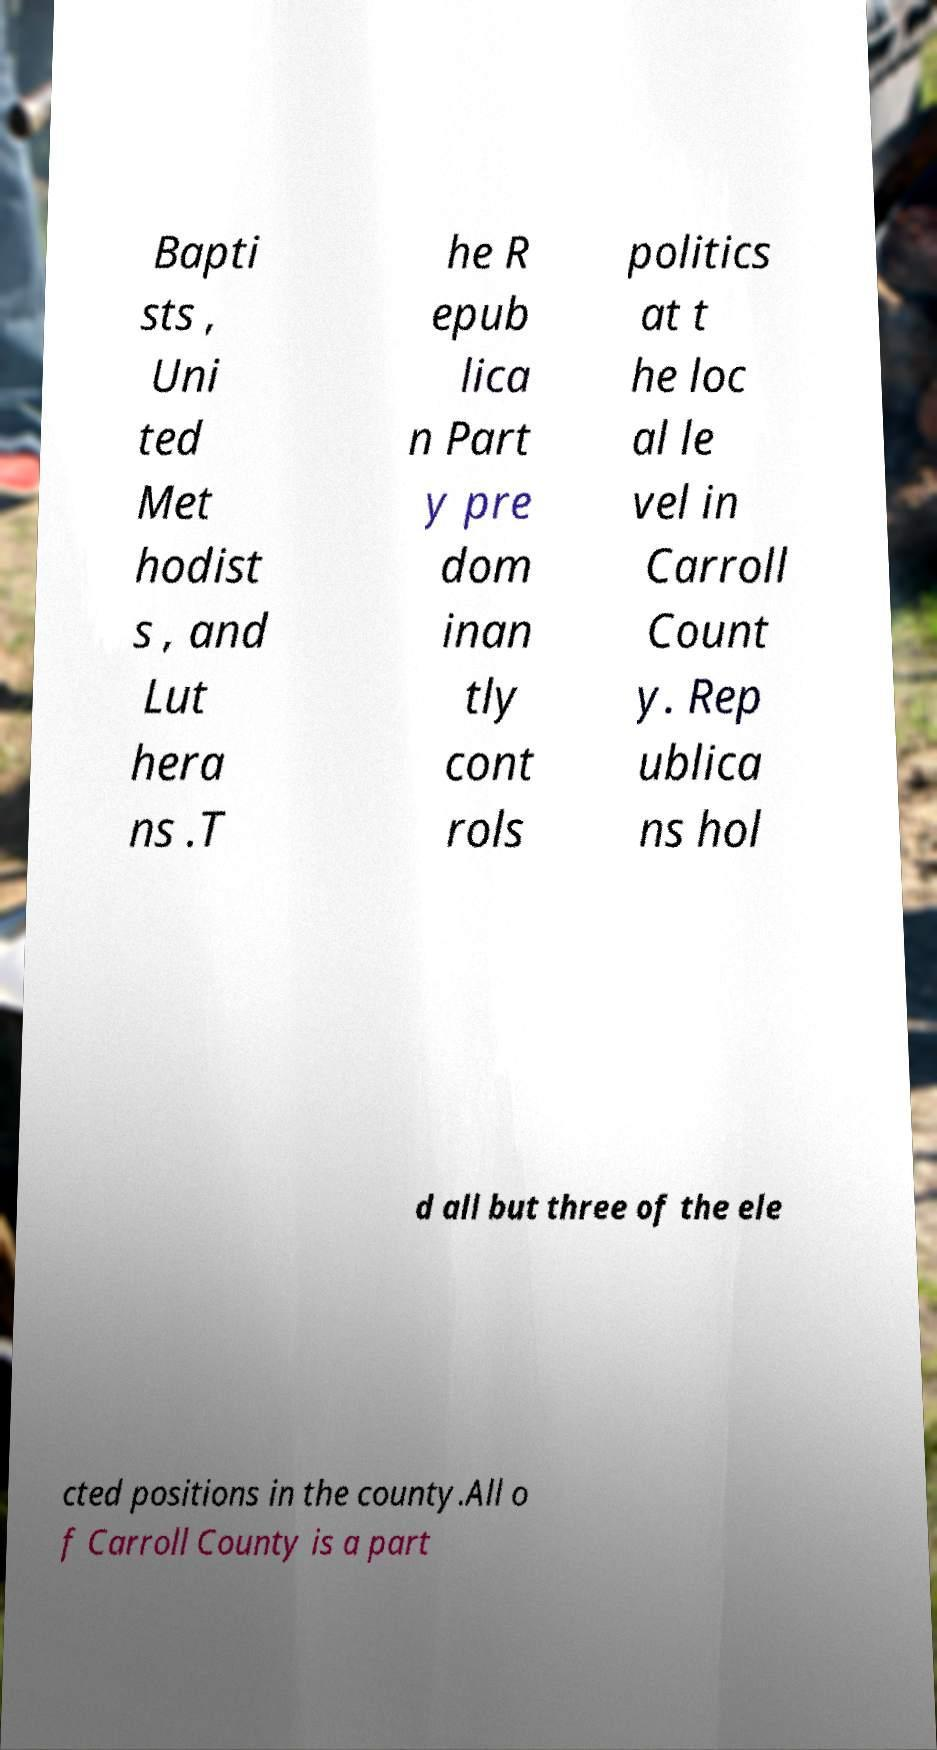Please read and relay the text visible in this image. What does it say? Bapti sts , Uni ted Met hodist s , and Lut hera ns .T he R epub lica n Part y pre dom inan tly cont rols politics at t he loc al le vel in Carroll Count y. Rep ublica ns hol d all but three of the ele cted positions in the county.All o f Carroll County is a part 